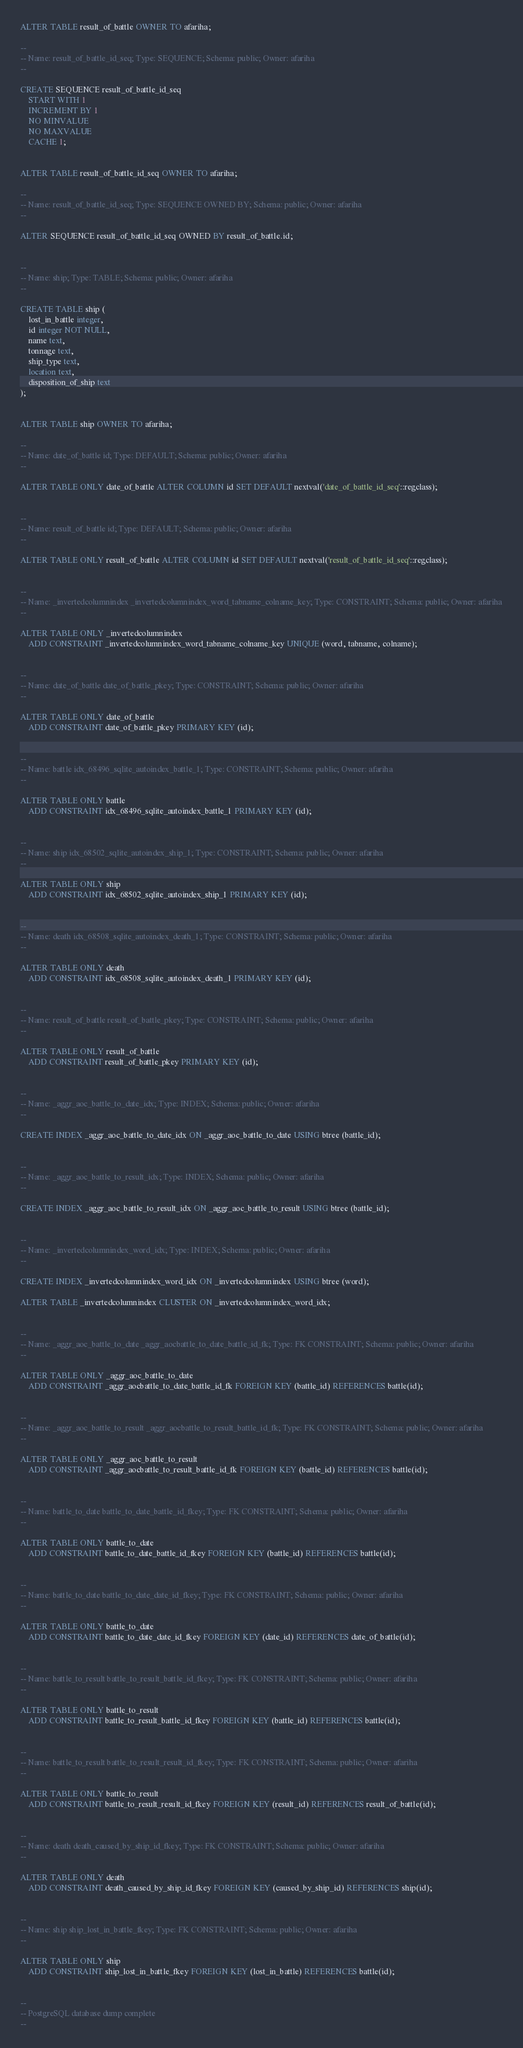<code> <loc_0><loc_0><loc_500><loc_500><_SQL_>

ALTER TABLE result_of_battle OWNER TO afariha;

--
-- Name: result_of_battle_id_seq; Type: SEQUENCE; Schema: public; Owner: afariha
--

CREATE SEQUENCE result_of_battle_id_seq
    START WITH 1
    INCREMENT BY 1
    NO MINVALUE
    NO MAXVALUE
    CACHE 1;


ALTER TABLE result_of_battle_id_seq OWNER TO afariha;

--
-- Name: result_of_battle_id_seq; Type: SEQUENCE OWNED BY; Schema: public; Owner: afariha
--

ALTER SEQUENCE result_of_battle_id_seq OWNED BY result_of_battle.id;


--
-- Name: ship; Type: TABLE; Schema: public; Owner: afariha
--

CREATE TABLE ship (
    lost_in_battle integer,
    id integer NOT NULL,
    name text,
    tonnage text,
    ship_type text,
    location text,
    disposition_of_ship text
);


ALTER TABLE ship OWNER TO afariha;

--
-- Name: date_of_battle id; Type: DEFAULT; Schema: public; Owner: afariha
--

ALTER TABLE ONLY date_of_battle ALTER COLUMN id SET DEFAULT nextval('date_of_battle_id_seq'::regclass);


--
-- Name: result_of_battle id; Type: DEFAULT; Schema: public; Owner: afariha
--

ALTER TABLE ONLY result_of_battle ALTER COLUMN id SET DEFAULT nextval('result_of_battle_id_seq'::regclass);


--
-- Name: _invertedcolumnindex _invertedcolumnindex_word_tabname_colname_key; Type: CONSTRAINT; Schema: public; Owner: afariha
--

ALTER TABLE ONLY _invertedcolumnindex
    ADD CONSTRAINT _invertedcolumnindex_word_tabname_colname_key UNIQUE (word, tabname, colname);


--
-- Name: date_of_battle date_of_battle_pkey; Type: CONSTRAINT; Schema: public; Owner: afariha
--

ALTER TABLE ONLY date_of_battle
    ADD CONSTRAINT date_of_battle_pkey PRIMARY KEY (id);


--
-- Name: battle idx_68496_sqlite_autoindex_battle_1; Type: CONSTRAINT; Schema: public; Owner: afariha
--

ALTER TABLE ONLY battle
    ADD CONSTRAINT idx_68496_sqlite_autoindex_battle_1 PRIMARY KEY (id);


--
-- Name: ship idx_68502_sqlite_autoindex_ship_1; Type: CONSTRAINT; Schema: public; Owner: afariha
--

ALTER TABLE ONLY ship
    ADD CONSTRAINT idx_68502_sqlite_autoindex_ship_1 PRIMARY KEY (id);


--
-- Name: death idx_68508_sqlite_autoindex_death_1; Type: CONSTRAINT; Schema: public; Owner: afariha
--

ALTER TABLE ONLY death
    ADD CONSTRAINT idx_68508_sqlite_autoindex_death_1 PRIMARY KEY (id);


--
-- Name: result_of_battle result_of_battle_pkey; Type: CONSTRAINT; Schema: public; Owner: afariha
--

ALTER TABLE ONLY result_of_battle
    ADD CONSTRAINT result_of_battle_pkey PRIMARY KEY (id);


--
-- Name: _aggr_aoc_battle_to_date_idx; Type: INDEX; Schema: public; Owner: afariha
--

CREATE INDEX _aggr_aoc_battle_to_date_idx ON _aggr_aoc_battle_to_date USING btree (battle_id);


--
-- Name: _aggr_aoc_battle_to_result_idx; Type: INDEX; Schema: public; Owner: afariha
--

CREATE INDEX _aggr_aoc_battle_to_result_idx ON _aggr_aoc_battle_to_result USING btree (battle_id);


--
-- Name: _invertedcolumnindex_word_idx; Type: INDEX; Schema: public; Owner: afariha
--

CREATE INDEX _invertedcolumnindex_word_idx ON _invertedcolumnindex USING btree (word);

ALTER TABLE _invertedcolumnindex CLUSTER ON _invertedcolumnindex_word_idx;


--
-- Name: _aggr_aoc_battle_to_date _aggr_aocbattle_to_date_battle_id_fk; Type: FK CONSTRAINT; Schema: public; Owner: afariha
--

ALTER TABLE ONLY _aggr_aoc_battle_to_date
    ADD CONSTRAINT _aggr_aocbattle_to_date_battle_id_fk FOREIGN KEY (battle_id) REFERENCES battle(id);


--
-- Name: _aggr_aoc_battle_to_result _aggr_aocbattle_to_result_battle_id_fk; Type: FK CONSTRAINT; Schema: public; Owner: afariha
--

ALTER TABLE ONLY _aggr_aoc_battle_to_result
    ADD CONSTRAINT _aggr_aocbattle_to_result_battle_id_fk FOREIGN KEY (battle_id) REFERENCES battle(id);


--
-- Name: battle_to_date battle_to_date_battle_id_fkey; Type: FK CONSTRAINT; Schema: public; Owner: afariha
--

ALTER TABLE ONLY battle_to_date
    ADD CONSTRAINT battle_to_date_battle_id_fkey FOREIGN KEY (battle_id) REFERENCES battle(id);


--
-- Name: battle_to_date battle_to_date_date_id_fkey; Type: FK CONSTRAINT; Schema: public; Owner: afariha
--

ALTER TABLE ONLY battle_to_date
    ADD CONSTRAINT battle_to_date_date_id_fkey FOREIGN KEY (date_id) REFERENCES date_of_battle(id);


--
-- Name: battle_to_result battle_to_result_battle_id_fkey; Type: FK CONSTRAINT; Schema: public; Owner: afariha
--

ALTER TABLE ONLY battle_to_result
    ADD CONSTRAINT battle_to_result_battle_id_fkey FOREIGN KEY (battle_id) REFERENCES battle(id);


--
-- Name: battle_to_result battle_to_result_result_id_fkey; Type: FK CONSTRAINT; Schema: public; Owner: afariha
--

ALTER TABLE ONLY battle_to_result
    ADD CONSTRAINT battle_to_result_result_id_fkey FOREIGN KEY (result_id) REFERENCES result_of_battle(id);


--
-- Name: death death_caused_by_ship_id_fkey; Type: FK CONSTRAINT; Schema: public; Owner: afariha
--

ALTER TABLE ONLY death
    ADD CONSTRAINT death_caused_by_ship_id_fkey FOREIGN KEY (caused_by_ship_id) REFERENCES ship(id);


--
-- Name: ship ship_lost_in_battle_fkey; Type: FK CONSTRAINT; Schema: public; Owner: afariha
--

ALTER TABLE ONLY ship
    ADD CONSTRAINT ship_lost_in_battle_fkey FOREIGN KEY (lost_in_battle) REFERENCES battle(id);


--
-- PostgreSQL database dump complete
--

</code> 